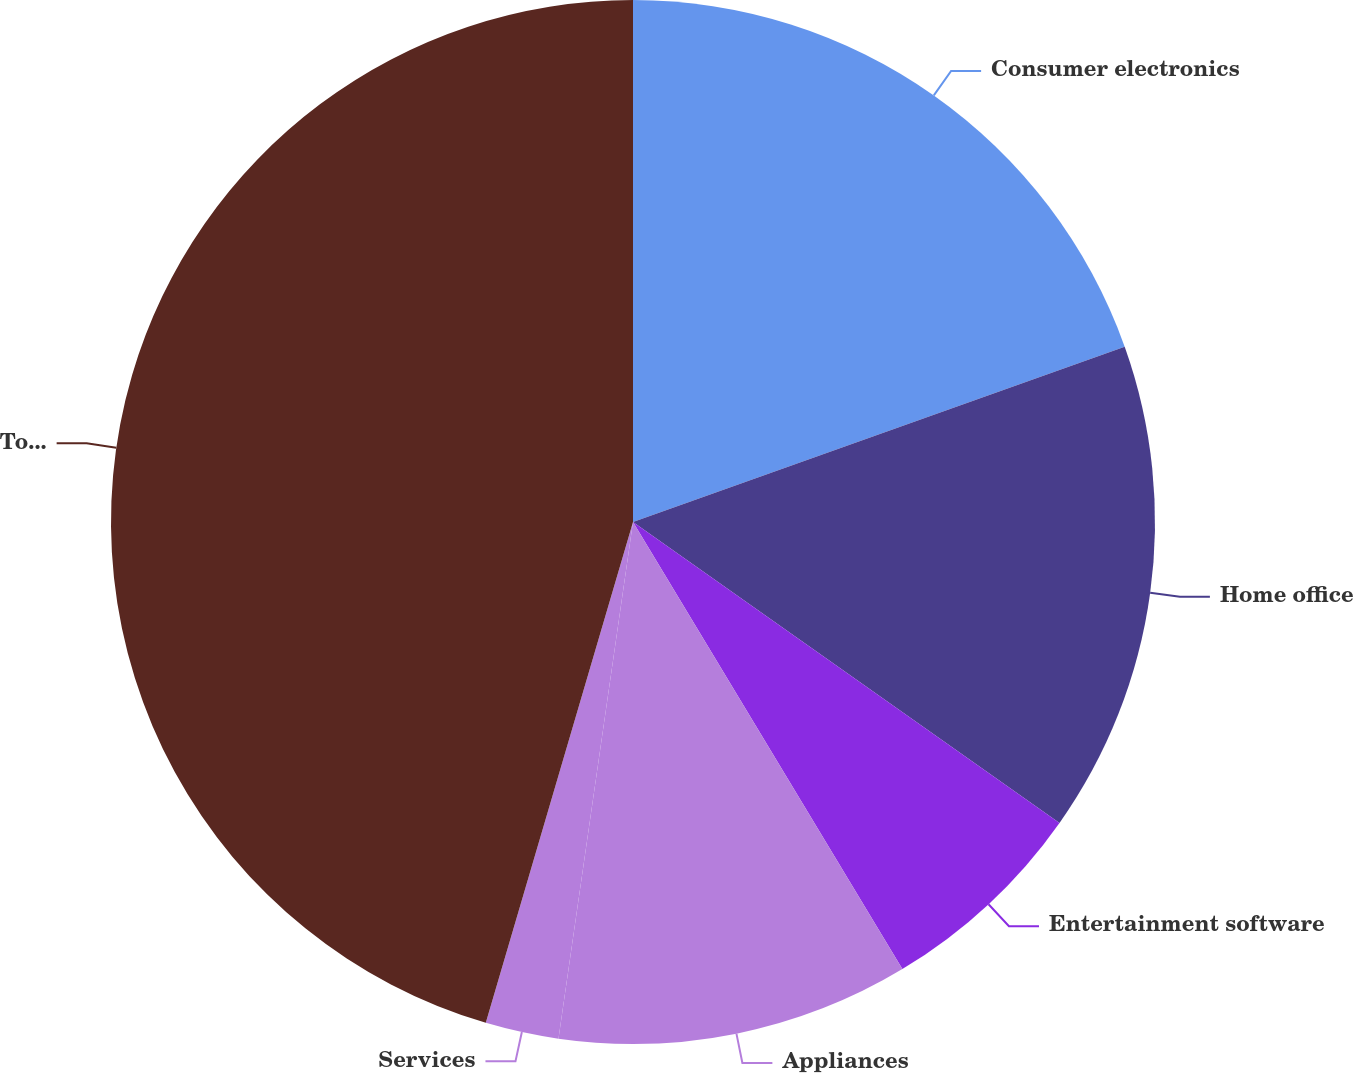<chart> <loc_0><loc_0><loc_500><loc_500><pie_chart><fcel>Consumer electronics<fcel>Home office<fcel>Entertainment software<fcel>Appliances<fcel>Services<fcel>Total<nl><fcel>19.55%<fcel>15.23%<fcel>6.59%<fcel>10.91%<fcel>2.27%<fcel>45.45%<nl></chart> 